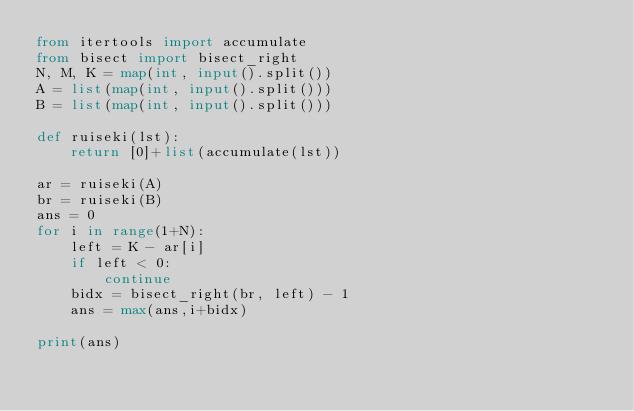<code> <loc_0><loc_0><loc_500><loc_500><_Python_>from itertools import accumulate
from bisect import bisect_right
N, M, K = map(int, input().split())
A = list(map(int, input().split()))
B = list(map(int, input().split()))

def ruiseki(lst):
    return [0]+list(accumulate(lst))

ar = ruiseki(A)
br = ruiseki(B)
ans = 0
for i in range(1+N):
    left = K - ar[i]
    if left < 0:
        continue
    bidx = bisect_right(br, left) - 1
    ans = max(ans,i+bidx)

print(ans)
</code> 